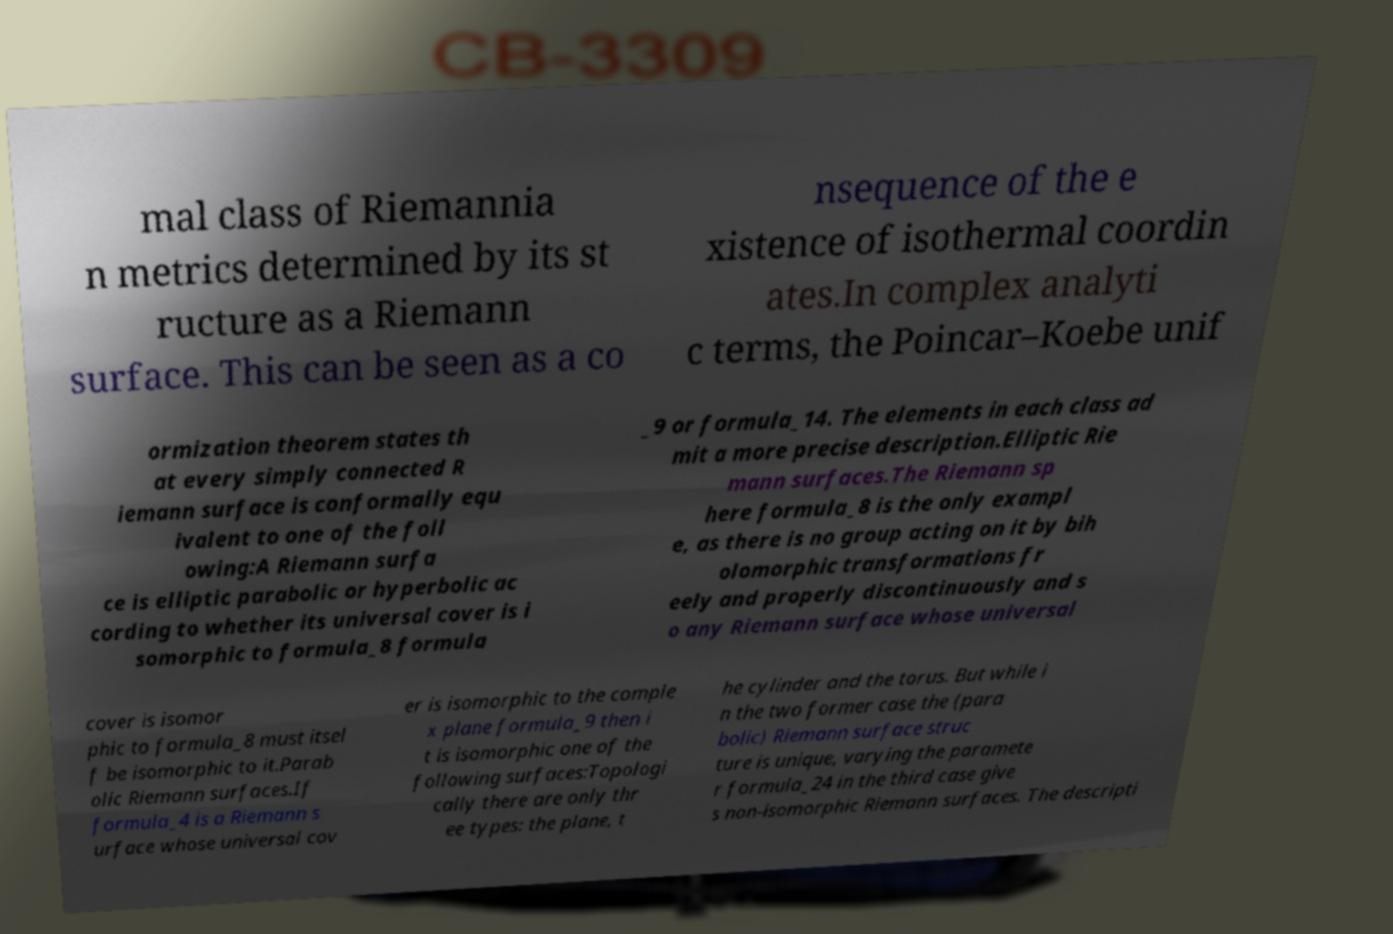Please read and relay the text visible in this image. What does it say? mal class of Riemannia n metrics determined by its st ructure as a Riemann surface. This can be seen as a co nsequence of the e xistence of isothermal coordin ates.In complex analyti c terms, the Poincar–Koebe unif ormization theorem states th at every simply connected R iemann surface is conformally equ ivalent to one of the foll owing:A Riemann surfa ce is elliptic parabolic or hyperbolic ac cording to whether its universal cover is i somorphic to formula_8 formula _9 or formula_14. The elements in each class ad mit a more precise description.Elliptic Rie mann surfaces.The Riemann sp here formula_8 is the only exampl e, as there is no group acting on it by bih olomorphic transformations fr eely and properly discontinuously and s o any Riemann surface whose universal cover is isomor phic to formula_8 must itsel f be isomorphic to it.Parab olic Riemann surfaces.If formula_4 is a Riemann s urface whose universal cov er is isomorphic to the comple x plane formula_9 then i t is isomorphic one of the following surfaces:Topologi cally there are only thr ee types: the plane, t he cylinder and the torus. But while i n the two former case the (para bolic) Riemann surface struc ture is unique, varying the paramete r formula_24 in the third case give s non-isomorphic Riemann surfaces. The descripti 